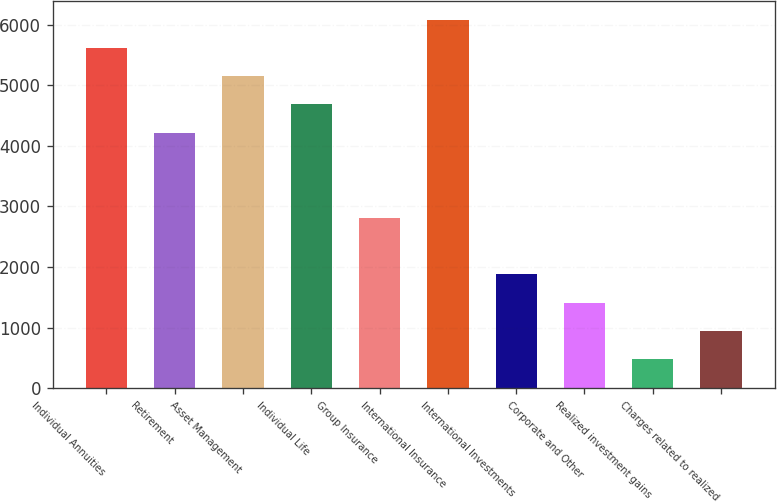Convert chart to OTSL. <chart><loc_0><loc_0><loc_500><loc_500><bar_chart><fcel>Individual Annuities<fcel>Retirement<fcel>Asset Management<fcel>Individual Life<fcel>Group Insurance<fcel>International Insurance<fcel>International Investments<fcel>Corporate and Other<fcel>Realized investment gains<fcel>Charges related to realized<nl><fcel>5617<fcel>4216<fcel>5150<fcel>4683<fcel>2815<fcel>6084<fcel>1881<fcel>1414<fcel>480<fcel>947<nl></chart> 